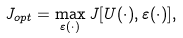<formula> <loc_0><loc_0><loc_500><loc_500>J _ { o p t } = \max _ { \varepsilon ( \cdot ) } J [ U ( \cdot ) , \varepsilon ( \cdot ) ] ,</formula> 